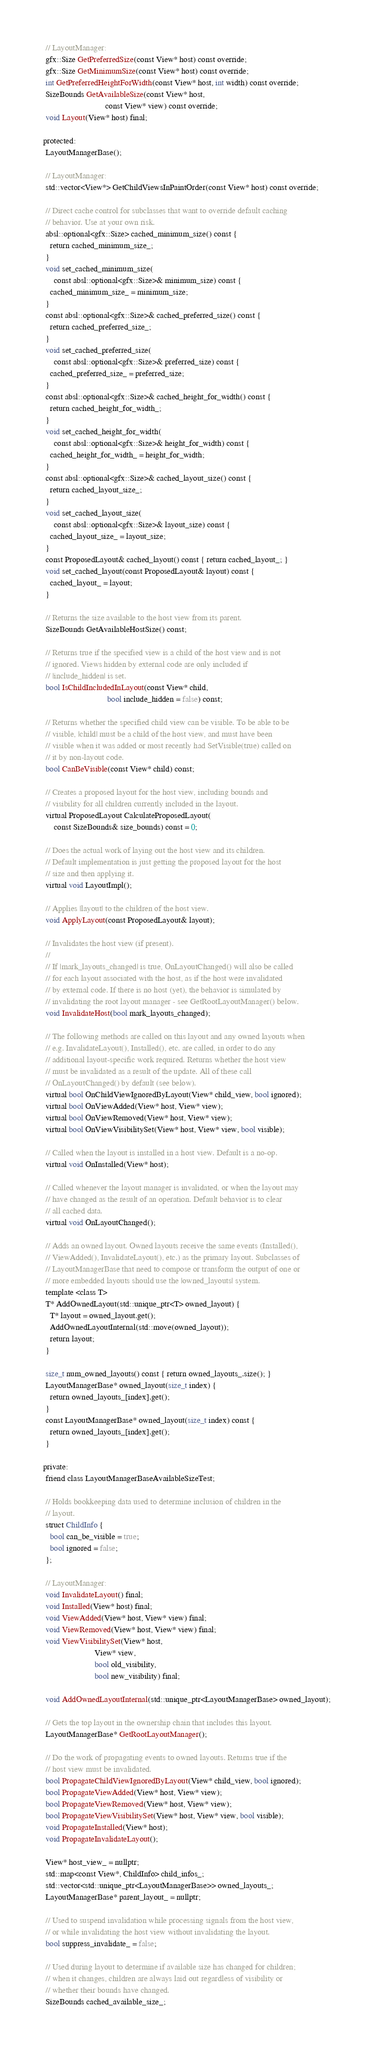<code> <loc_0><loc_0><loc_500><loc_500><_C_>  // LayoutManager:
  gfx::Size GetPreferredSize(const View* host) const override;
  gfx::Size GetMinimumSize(const View* host) const override;
  int GetPreferredHeightForWidth(const View* host, int width) const override;
  SizeBounds GetAvailableSize(const View* host,
                              const View* view) const override;
  void Layout(View* host) final;

 protected:
  LayoutManagerBase();

  // LayoutManager:
  std::vector<View*> GetChildViewsInPaintOrder(const View* host) const override;

  // Direct cache control for subclasses that want to override default caching
  // behavior. Use at your own risk.
  absl::optional<gfx::Size> cached_minimum_size() const {
    return cached_minimum_size_;
  }
  void set_cached_minimum_size(
      const absl::optional<gfx::Size>& minimum_size) const {
    cached_minimum_size_ = minimum_size;
  }
  const absl::optional<gfx::Size>& cached_preferred_size() const {
    return cached_preferred_size_;
  }
  void set_cached_preferred_size(
      const absl::optional<gfx::Size>& preferred_size) const {
    cached_preferred_size_ = preferred_size;
  }
  const absl::optional<gfx::Size>& cached_height_for_width() const {
    return cached_height_for_width_;
  }
  void set_cached_height_for_width(
      const absl::optional<gfx::Size>& height_for_width) const {
    cached_height_for_width_ = height_for_width;
  }
  const absl::optional<gfx::Size>& cached_layout_size() const {
    return cached_layout_size_;
  }
  void set_cached_layout_size(
      const absl::optional<gfx::Size>& layout_size) const {
    cached_layout_size_ = layout_size;
  }
  const ProposedLayout& cached_layout() const { return cached_layout_; }
  void set_cached_layout(const ProposedLayout& layout) const {
    cached_layout_ = layout;
  }

  // Returns the size available to the host view from its parent.
  SizeBounds GetAvailableHostSize() const;

  // Returns true if the specified view is a child of the host view and is not
  // ignored. Views hidden by external code are only included if
  // |include_hidden| is set.
  bool IsChildIncludedInLayout(const View* child,
                               bool include_hidden = false) const;

  // Returns whether the specified child view can be visible. To be able to be
  // visible, |child| must be a child of the host view, and must have been
  // visible when it was added or most recently had SetVisible(true) called on
  // it by non-layout code.
  bool CanBeVisible(const View* child) const;

  // Creates a proposed layout for the host view, including bounds and
  // visibility for all children currently included in the layout.
  virtual ProposedLayout CalculateProposedLayout(
      const SizeBounds& size_bounds) const = 0;

  // Does the actual work of laying out the host view and its children.
  // Default implementation is just getting the proposed layout for the host
  // size and then applying it.
  virtual void LayoutImpl();

  // Applies |layout| to the children of the host view.
  void ApplyLayout(const ProposedLayout& layout);

  // Invalidates the host view (if present).
  //
  // If |mark_layouts_changed| is true, OnLayoutChanged() will also be called
  // for each layout associated with the host, as if the host were invalidated
  // by external code. If there is no host (yet), the behavior is simulated by
  // invalidating the root layout manager - see GetRootLayoutManager() below.
  void InvalidateHost(bool mark_layouts_changed);

  // The following methods are called on this layout and any owned layouts when
  // e.g. InvalidateLayout(), Installed(), etc. are called, in order to do any
  // additional layout-specific work required. Returns whether the host view
  // must be invalidated as a result of the update. All of these call
  // OnLayoutChanged() by default (see below).
  virtual bool OnChildViewIgnoredByLayout(View* child_view, bool ignored);
  virtual bool OnViewAdded(View* host, View* view);
  virtual bool OnViewRemoved(View* host, View* view);
  virtual bool OnViewVisibilitySet(View* host, View* view, bool visible);

  // Called when the layout is installed in a host view. Default is a no-op.
  virtual void OnInstalled(View* host);

  // Called whenever the layout manager is invalidated, or when the layout may
  // have changed as the result of an operation. Default behavior is to clear
  // all cached data.
  virtual void OnLayoutChanged();

  // Adds an owned layout. Owned layouts receive the same events (Installed(),
  // ViewAdded(), InvalidateLayout(), etc.) as the primary layout. Subclasses of
  // LayoutManagerBase that need to compose or transform the output of one or
  // more embedded layouts should use the |owned_layouts| system.
  template <class T>
  T* AddOwnedLayout(std::unique_ptr<T> owned_layout) {
    T* layout = owned_layout.get();
    AddOwnedLayoutInternal(std::move(owned_layout));
    return layout;
  }

  size_t num_owned_layouts() const { return owned_layouts_.size(); }
  LayoutManagerBase* owned_layout(size_t index) {
    return owned_layouts_[index].get();
  }
  const LayoutManagerBase* owned_layout(size_t index) const {
    return owned_layouts_[index].get();
  }

 private:
  friend class LayoutManagerBaseAvailableSizeTest;

  // Holds bookkeeping data used to determine inclusion of children in the
  // layout.
  struct ChildInfo {
    bool can_be_visible = true;
    bool ignored = false;
  };

  // LayoutManager:
  void InvalidateLayout() final;
  void Installed(View* host) final;
  void ViewAdded(View* host, View* view) final;
  void ViewRemoved(View* host, View* view) final;
  void ViewVisibilitySet(View* host,
                         View* view,
                         bool old_visibility,
                         bool new_visibility) final;

  void AddOwnedLayoutInternal(std::unique_ptr<LayoutManagerBase> owned_layout);

  // Gets the top layout in the ownership chain that includes this layout.
  LayoutManagerBase* GetRootLayoutManager();

  // Do the work of propagating events to owned layouts. Returns true if the
  // host view must be invalidated.
  bool PropagateChildViewIgnoredByLayout(View* child_view, bool ignored);
  bool PropagateViewAdded(View* host, View* view);
  bool PropagateViewRemoved(View* host, View* view);
  bool PropagateViewVisibilitySet(View* host, View* view, bool visible);
  void PropagateInstalled(View* host);
  void PropagateInvalidateLayout();

  View* host_view_ = nullptr;
  std::map<const View*, ChildInfo> child_infos_;
  std::vector<std::unique_ptr<LayoutManagerBase>> owned_layouts_;
  LayoutManagerBase* parent_layout_ = nullptr;

  // Used to suspend invalidation while processing signals from the host view,
  // or while invalidating the host view without invalidating the layout.
  bool suppress_invalidate_ = false;

  // Used during layout to determine if available size has changed for children;
  // when it changes, children are always laid out regardless of visibility or
  // whether their bounds have changed.
  SizeBounds cached_available_size_;
</code> 